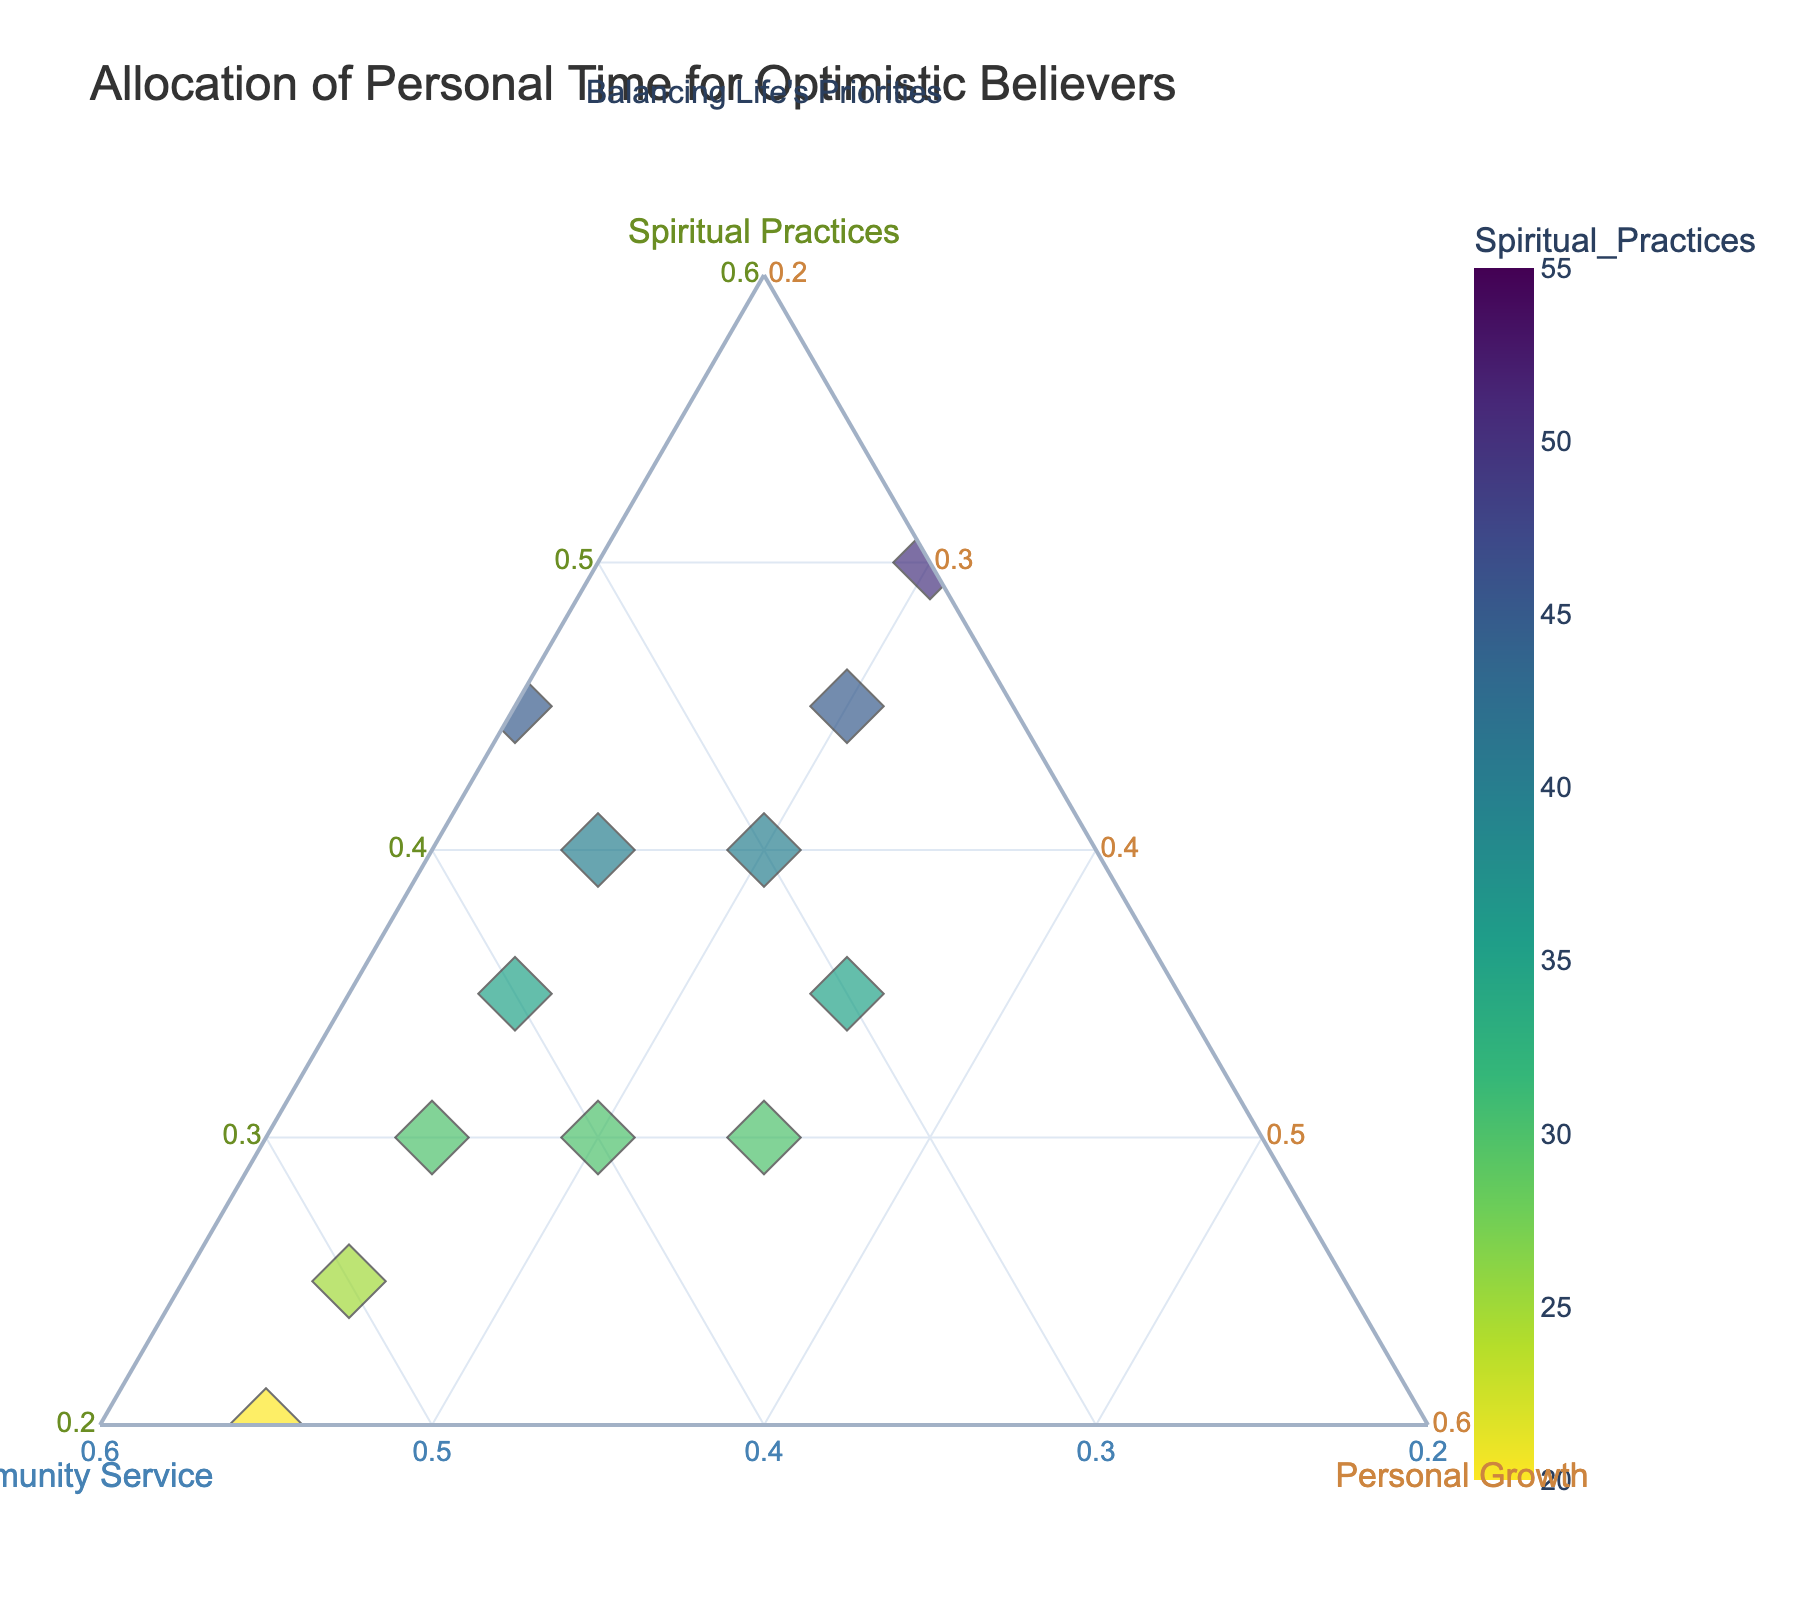What are the three categories shown in the ternary plot? The three categories are evident from the axis titles on the ternary plot. They are Spiritual Practices, Community Service, and Personal Growth.
Answer: Spiritual Practices, Community Service, Personal Growth What is the main title of the ternary plot? The title is displayed prominently at the top of the plot. It reads "Allocation of Personal Time for Optimistic Believers."
Answer: Allocation of Personal Time for Optimistic Believers How many points are plotted in the ternary plot? By counting each unique data point in the plot, we can see there are 13 points, each representing a different individual.
Answer: 13 Which individual has the highest allocation for Community Service? By examining the points placed along the axis for Community Service, the individual at 55% is Soup Kitchen Manager Lisa, indicating she has the highest allocation.
Answer: Soup Kitchen Manager Lisa Which individual has an equal allocation for Personal Growth and Spiritual Practices? Looking for points where the coordinates for Personal Growth and Spiritual Practices are the same, we find Deacon Smith with 35% each for Personal Growth and Spiritual Practices.
Answer: Deacon Smith What is the average amount of time allocated to Spiritual Practices by all individuals? To find the average, sum all Spiritual Practices percentages (40+30+50+35+25+45+30+55+20+40+35+45+30) which equals 480, and then divide by the number of individuals, 13. The average is 480/13 ≈ 36.92%.
Answer: 36.92% Who has the lowest allocation for Personal Growth, and what is the value? Scanning for the smallest value on the Personal Growth axis, Worship Team Leader Jacob has the lowest allocation with 20%.
Answer: Worship Team Leader Jacob, 20% Which activity has the widest range of allocation among individuals? Checking the ranges for each category, Spiritual Practices ranges from 20% to 55%, Community Service ranges from 15% to 55%, and Personal Growth ranges from 20% to 35%. The widest range is for Community Service (55-15=40%).
Answer: Community Service Which axis represents the activity with the smallest minimum allocation value observed? Observing each axis, the smallest allocation shown in the plot is 15% for Community Service, found in Prayer Group Organizer Michael's data.
Answer: Community Service Which individuals have an allocation of 45% for Spiritual Practices? Looking at the ternary plot and seeking 45% on the Spiritual Practices axis, Meditation Leader David and Worship Team Leader Jacob meet this criterion.
Answer: Meditation Leader David, Worship Team Leader Jacob 